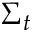<formula> <loc_0><loc_0><loc_500><loc_500>\Sigma _ { t }</formula> 